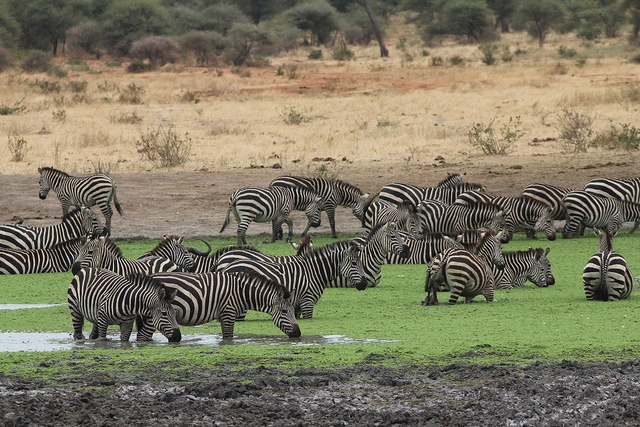Describe the objects in this image and their specific colors. I can see zebra in gray, black, and darkgray tones, zebra in gray, black, and darkgray tones, zebra in gray, black, and darkgray tones, zebra in gray, black, and darkgray tones, and zebra in gray, black, and darkgray tones in this image. 